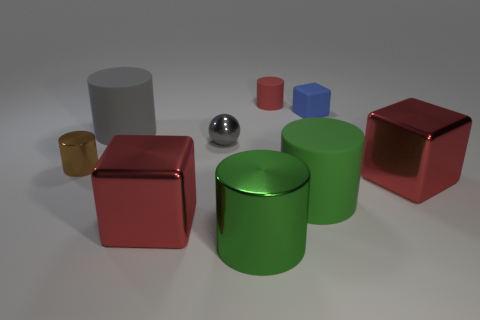Can you describe the colors and shapes of the objects in the center of the image? In the center of the image, there are several objects. Prominently, there is a large gray cylinder, a shiny metallic sphere, and a green cylindrical object. These items vary in shape and material, contributing to a visually interesting setup. 